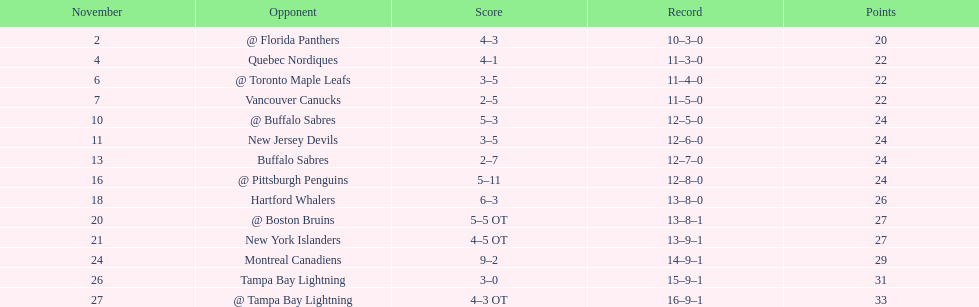Could you help me parse every detail presented in this table? {'header': ['November', 'Opponent', 'Score', 'Record', 'Points'], 'rows': [['2', '@ Florida Panthers', '4–3', '10–3–0', '20'], ['4', 'Quebec Nordiques', '4–1', '11–3–0', '22'], ['6', '@ Toronto Maple Leafs', '3–5', '11–4–0', '22'], ['7', 'Vancouver Canucks', '2–5', '11–5–0', '22'], ['10', '@ Buffalo Sabres', '5–3', '12–5–0', '24'], ['11', 'New Jersey Devils', '3–5', '12–6–0', '24'], ['13', 'Buffalo Sabres', '2–7', '12–7–0', '24'], ['16', '@ Pittsburgh Penguins', '5–11', '12–8–0', '24'], ['18', 'Hartford Whalers', '6–3', '13–8–0', '26'], ['20', '@ Boston Bruins', '5–5 OT', '13–8–1', '27'], ['21', 'New York Islanders', '4–5 OT', '13–9–1', '27'], ['24', 'Montreal Canadiens', '9–2', '14–9–1', '29'], ['26', 'Tampa Bay Lightning', '3–0', '15–9–1', '31'], ['27', '@ Tampa Bay Lightning', '4–3 OT', '16–9–1', '33']]} What was the total penalty minutes that dave brown had on the 1993-1994 flyers? 137. 